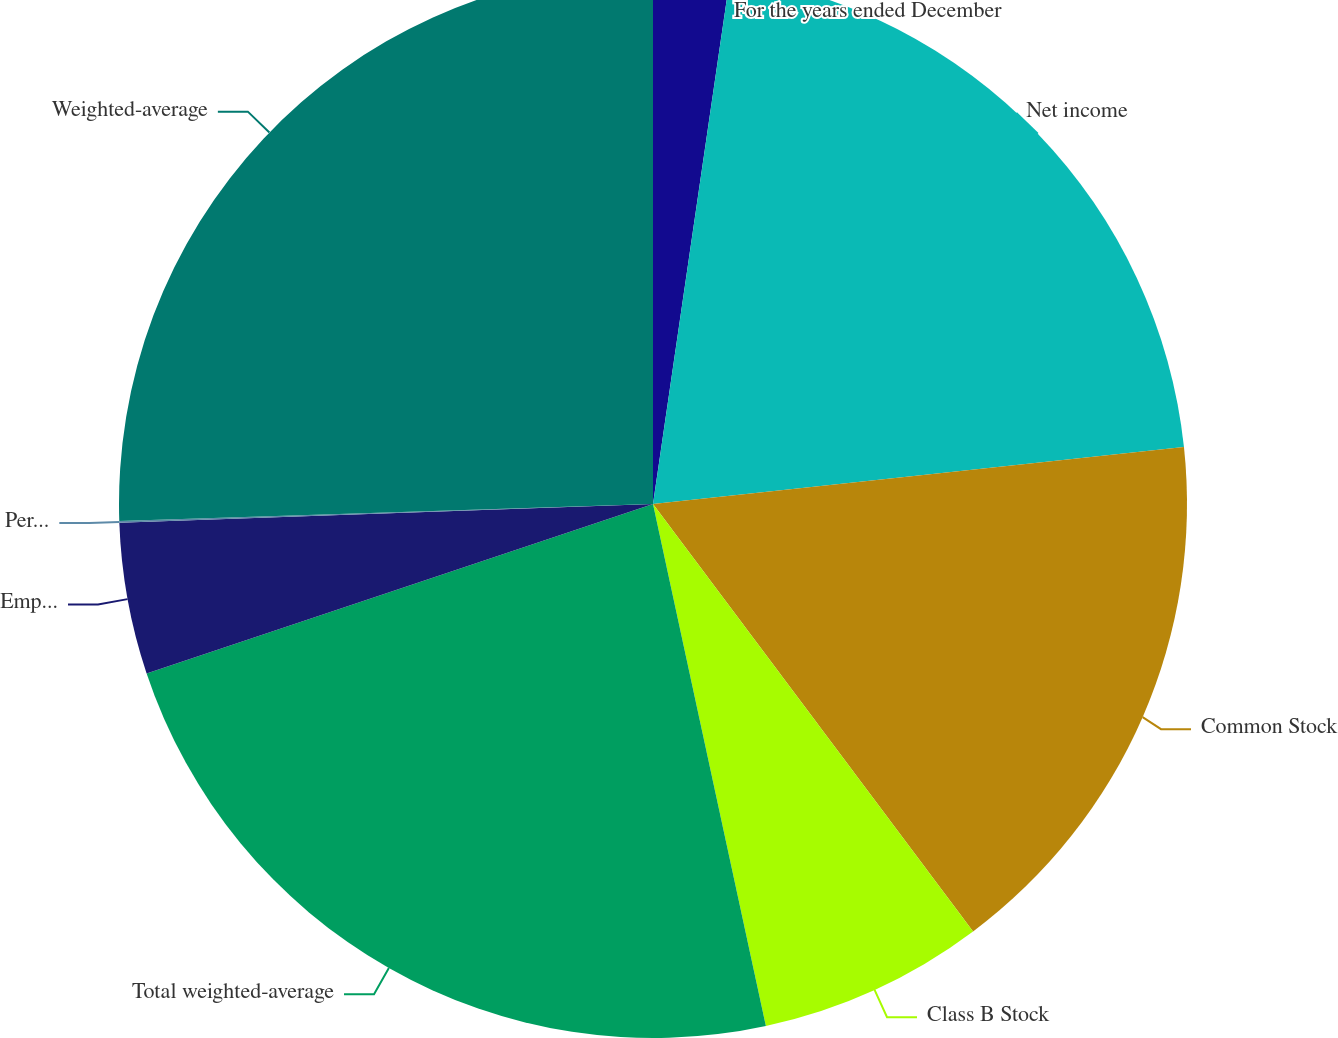Convert chart to OTSL. <chart><loc_0><loc_0><loc_500><loc_500><pie_chart><fcel>For the years ended December<fcel>Net income<fcel>Common Stock<fcel>Class B Stock<fcel>Total weighted-average<fcel>Employee stock options<fcel>Performance and restricted<fcel>Weighted-average<nl><fcel>2.31%<fcel>20.99%<fcel>16.47%<fcel>6.84%<fcel>23.25%<fcel>4.58%<fcel>0.05%<fcel>25.51%<nl></chart> 